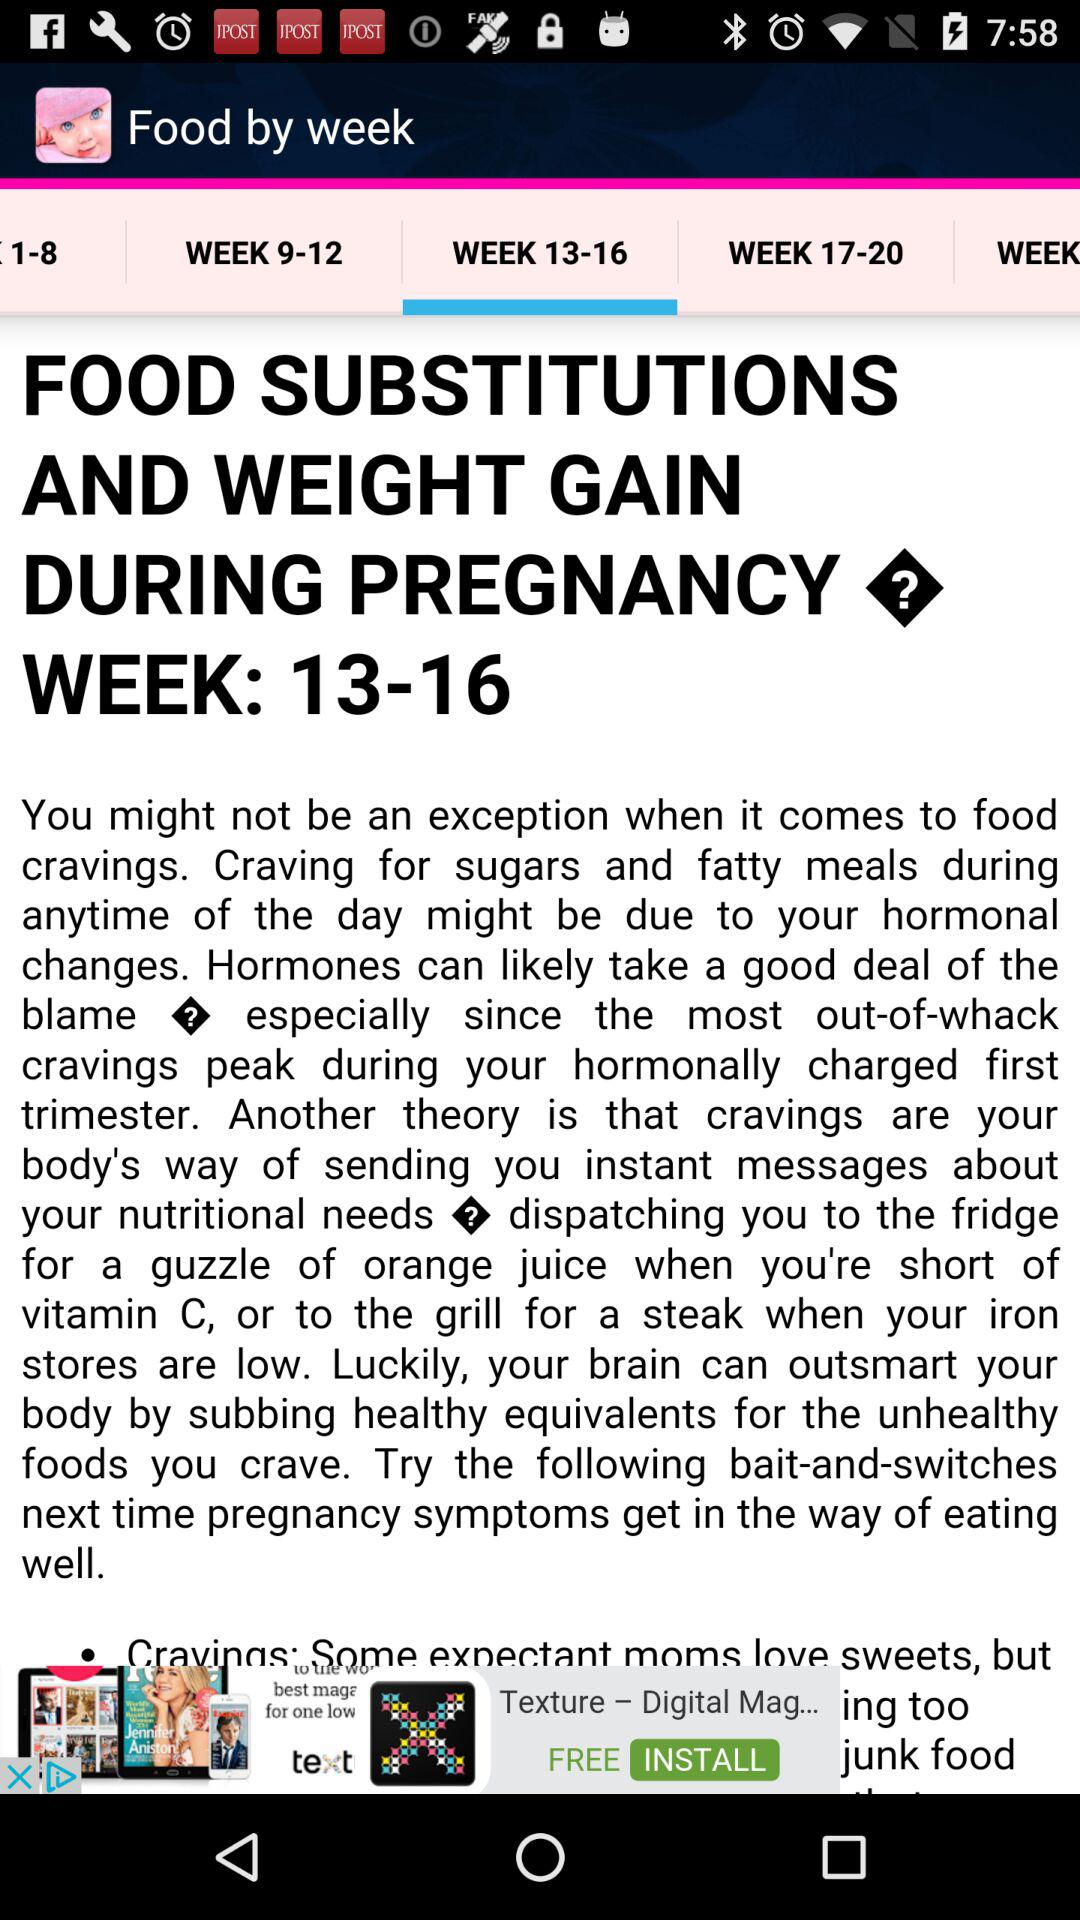How many weeks of pregnancy are covered in this article?
Answer the question using a single word or phrase. 13-16 